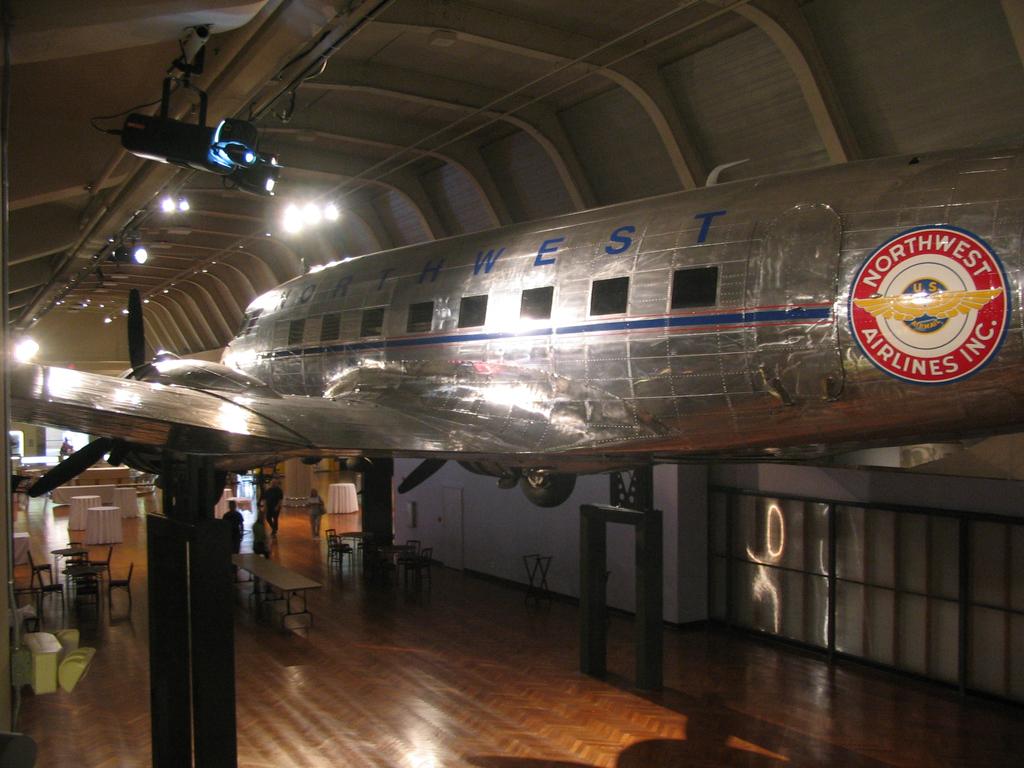Which airline is this?
Your response must be concise. Northwest. 